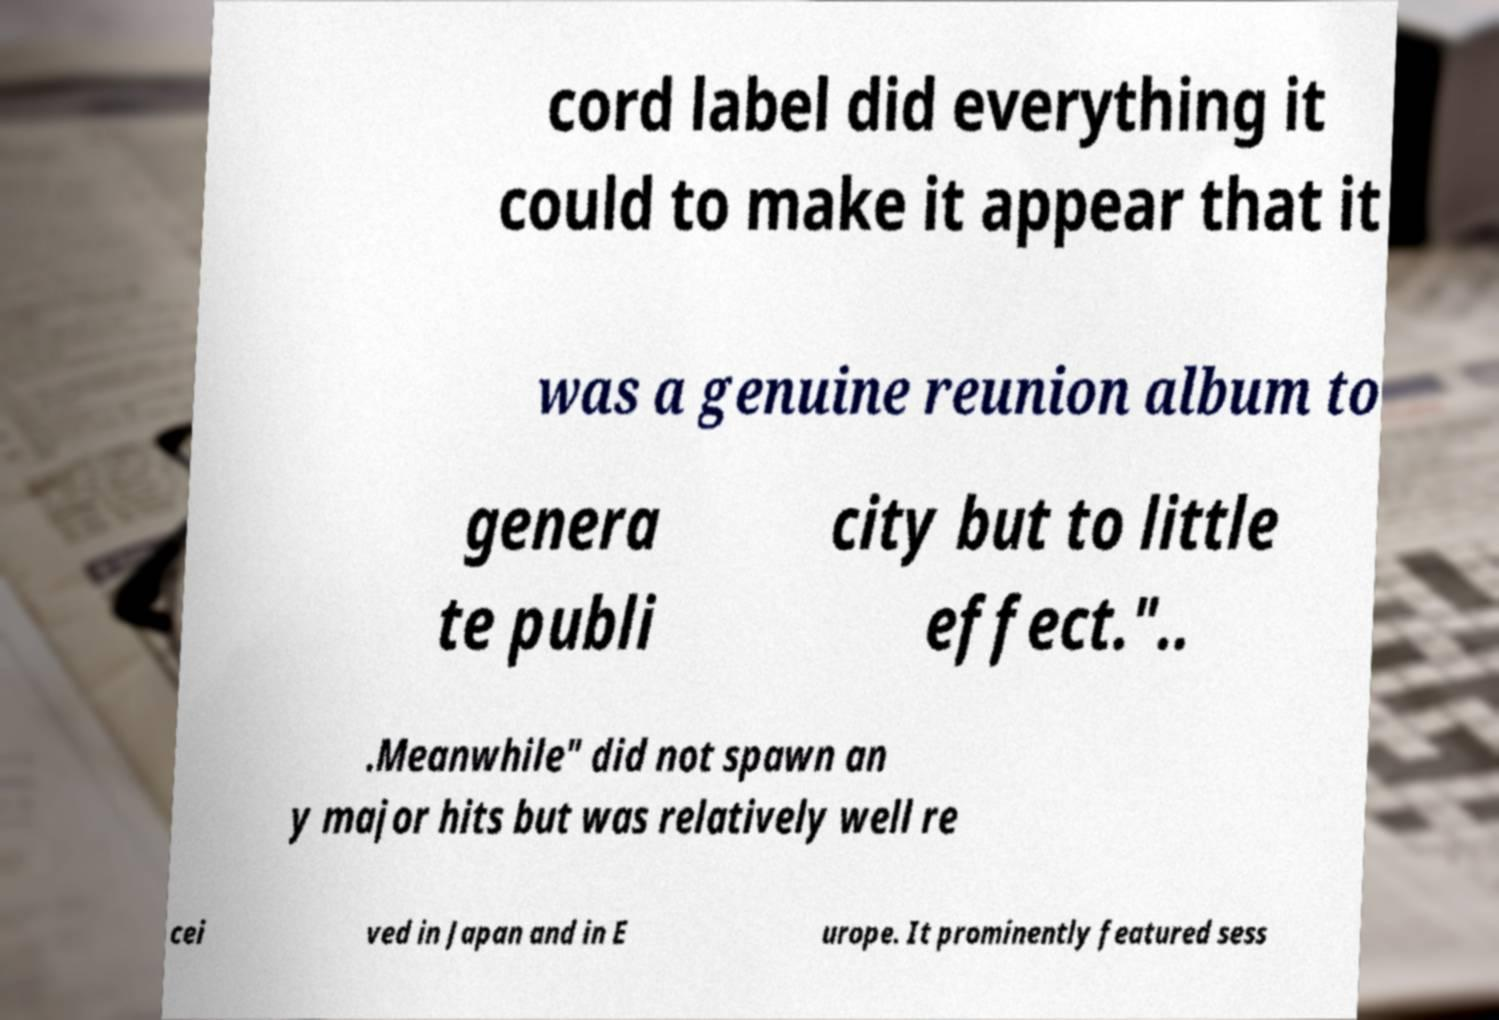Please identify and transcribe the text found in this image. cord label did everything it could to make it appear that it was a genuine reunion album to genera te publi city but to little effect.".. .Meanwhile" did not spawn an y major hits but was relatively well re cei ved in Japan and in E urope. It prominently featured sess 